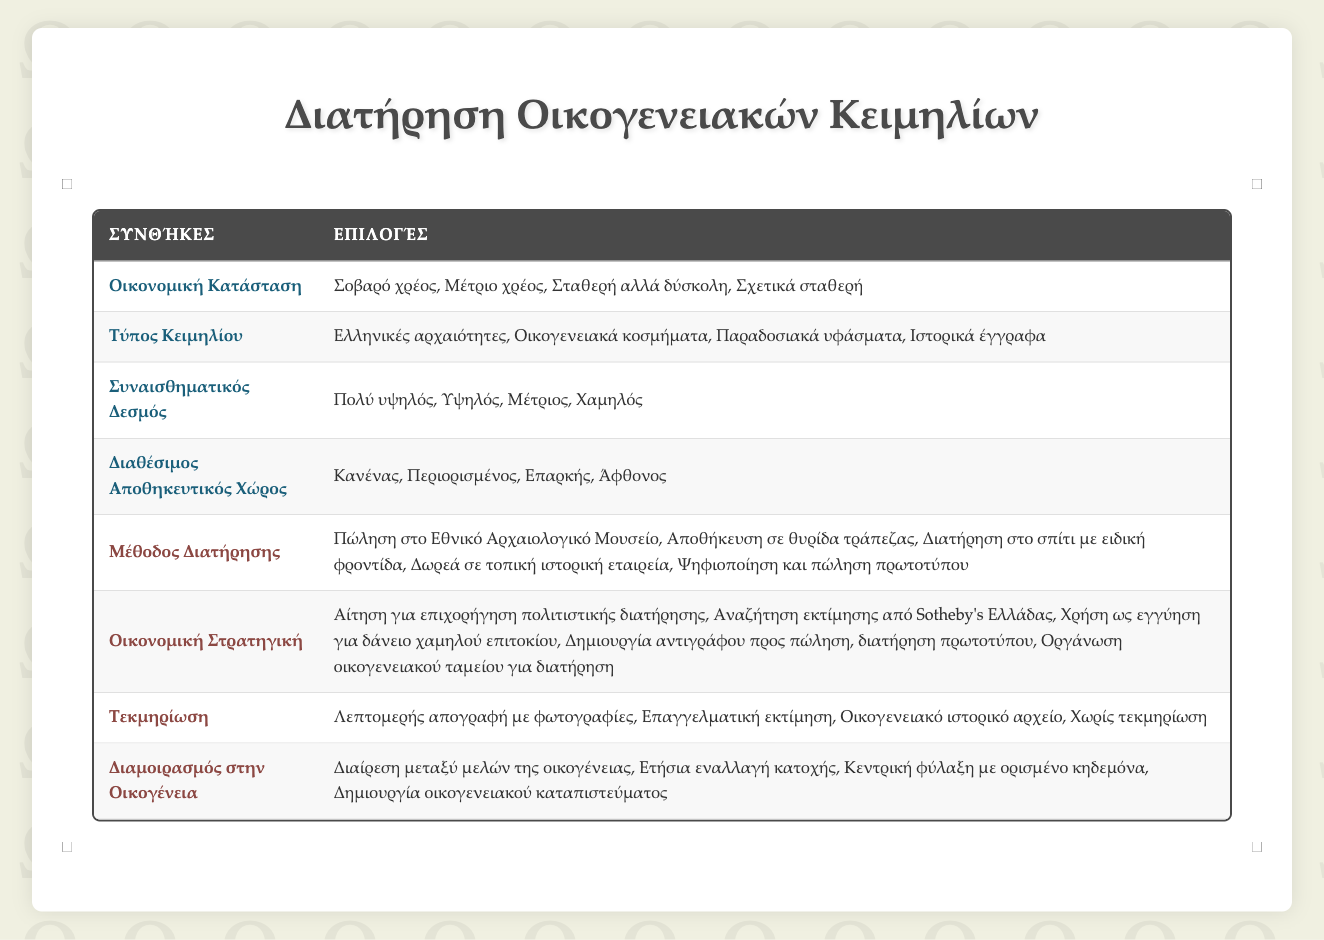What are the options for the type of heirloom? The table lists four options under "Heirloom Type": Greek antiquities, Family jewelry, Traditional textiles, and Historic documents.
Answer: Greek antiquities, Family jewelry, Traditional textiles, Historic documents If the financial situation is "Severe debt," what preservation method is suggested? The table provides various actions, but does not specify a direct method for "Severe debt." Typically, under such financial strain, one might consider selling or digitizing heirlooms, though this is not explicitly indicated for this situation.
Answer: Not explicitly mentioned Is "Rotate possession annually" an option for sharing heirlooms with family? Yes, the table lists "Rotate possession annually" as one of the options under "Sharing with Family."
Answer: Yes What is the relationship between "Emotional Attachment" and "Financial Strategy"? To determine a relationship, we analyze emotional attachment levels and the associated financial strategy options. High emotional attachment might lead to strategies focused more on preservation, like creating a family fund, while lower attachment could lean towards selling or digitizing. However, the table does not provide specific pairs, thus no direct relationship can be established.
Answer: No direct relationship stated If a family has "Adequate" storage space and "High" emotional attachment, what are their potential preservation methods? The options for preservation methods are: Keep at home with special care, Store in bank safety deposit box, and Donate to local historical society. Given the emotional attachment, "Keep at home with special care" is likely the most preferred method.
Answer: Keep at home with special care What is the recommended documentation type to be prepared in "Moderate debt" situations? In "Moderate debt," while the table does not specify directly, the most beneficial documentation would likely be a detailed inventory with photos to assess value and aid in financial strategies, reflecting moderate need for preservation versus assessment.
Answer: Detailed inventory with photos How many actions are available for "Financial Strategy"? The table enumerates five actions under "Financial Strategy": Apply for cultural preservation grant, Seek valuation from Sotheby's Greece, Use as collateral for low-interest loan, Create replica for sale, keep original, and Organize family fund for preservation.
Answer: Five actions Does having "No documentation" affect potential preservation methods? Yes, having "No documentation" can significantly limit options as proper records might be needed for selling or preserving items through grants or loan strategies. The lack of documentation could steer a family towards more immediate solutions like selling.
Answer: Yes If the heirloom type is "Family jewelry" and the financial situation is "Relatively stable," what preservation method might be preferred? A relatively stable financial situation would likely allow for more options. Keeping family jewelry at home with special care would align well with the emotional aspects of family heirlooms, especially if emotional attachment is also high.
Answer: Keep at home with special care 